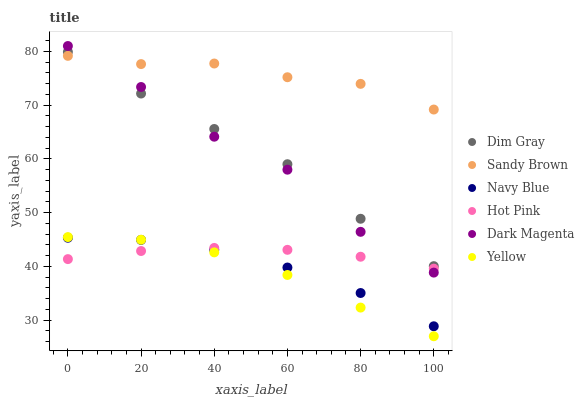Does Yellow have the minimum area under the curve?
Answer yes or no. Yes. Does Sandy Brown have the maximum area under the curve?
Answer yes or no. Yes. Does Dark Magenta have the minimum area under the curve?
Answer yes or no. No. Does Dark Magenta have the maximum area under the curve?
Answer yes or no. No. Is Hot Pink the smoothest?
Answer yes or no. Yes. Is Dark Magenta the roughest?
Answer yes or no. Yes. Is Navy Blue the smoothest?
Answer yes or no. No. Is Navy Blue the roughest?
Answer yes or no. No. Does Yellow have the lowest value?
Answer yes or no. Yes. Does Dark Magenta have the lowest value?
Answer yes or no. No. Does Dark Magenta have the highest value?
Answer yes or no. Yes. Does Navy Blue have the highest value?
Answer yes or no. No. Is Hot Pink less than Sandy Brown?
Answer yes or no. Yes. Is Sandy Brown greater than Hot Pink?
Answer yes or no. Yes. Does Navy Blue intersect Yellow?
Answer yes or no. Yes. Is Navy Blue less than Yellow?
Answer yes or no. No. Is Navy Blue greater than Yellow?
Answer yes or no. No. Does Hot Pink intersect Sandy Brown?
Answer yes or no. No. 